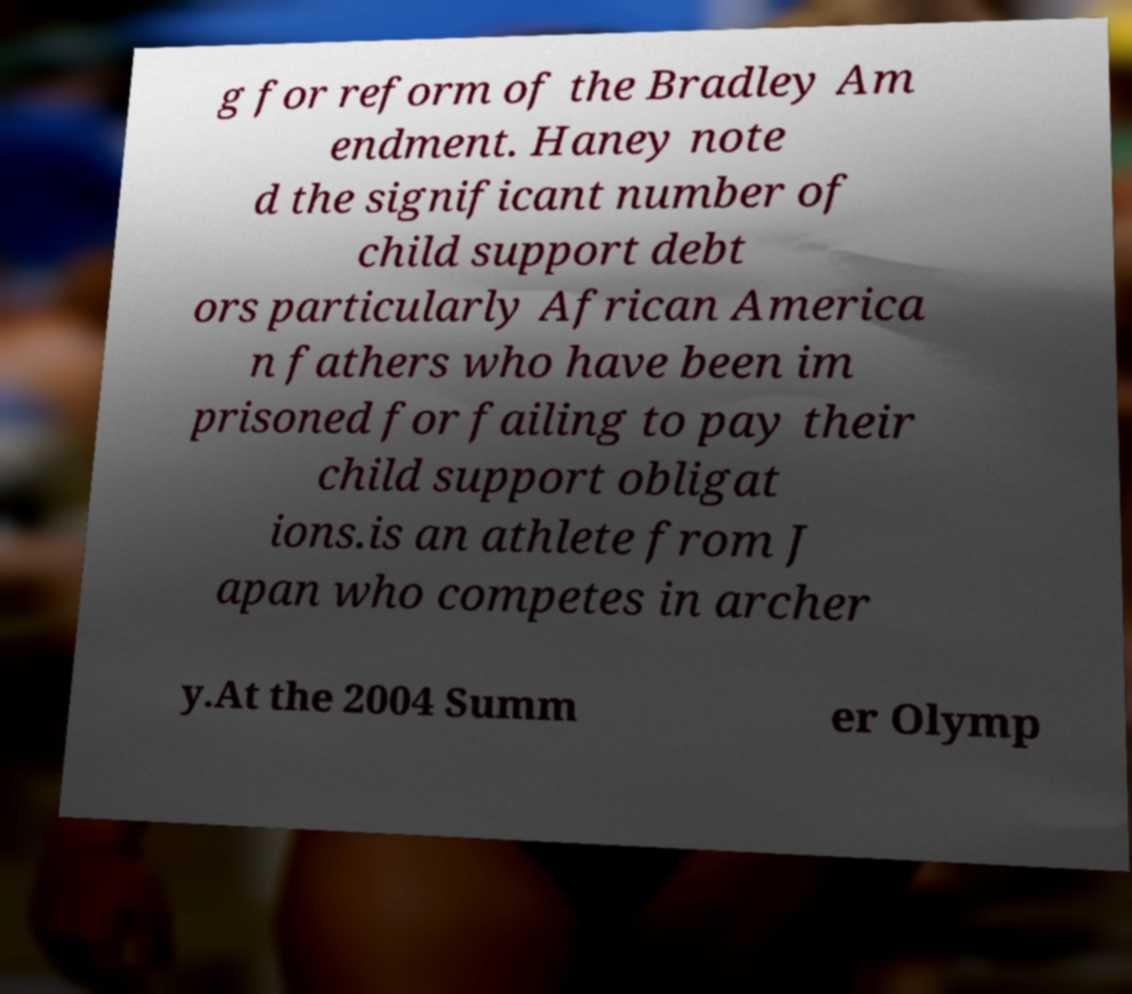Can you read and provide the text displayed in the image?This photo seems to have some interesting text. Can you extract and type it out for me? g for reform of the Bradley Am endment. Haney note d the significant number of child support debt ors particularly African America n fathers who have been im prisoned for failing to pay their child support obligat ions.is an athlete from J apan who competes in archer y.At the 2004 Summ er Olymp 